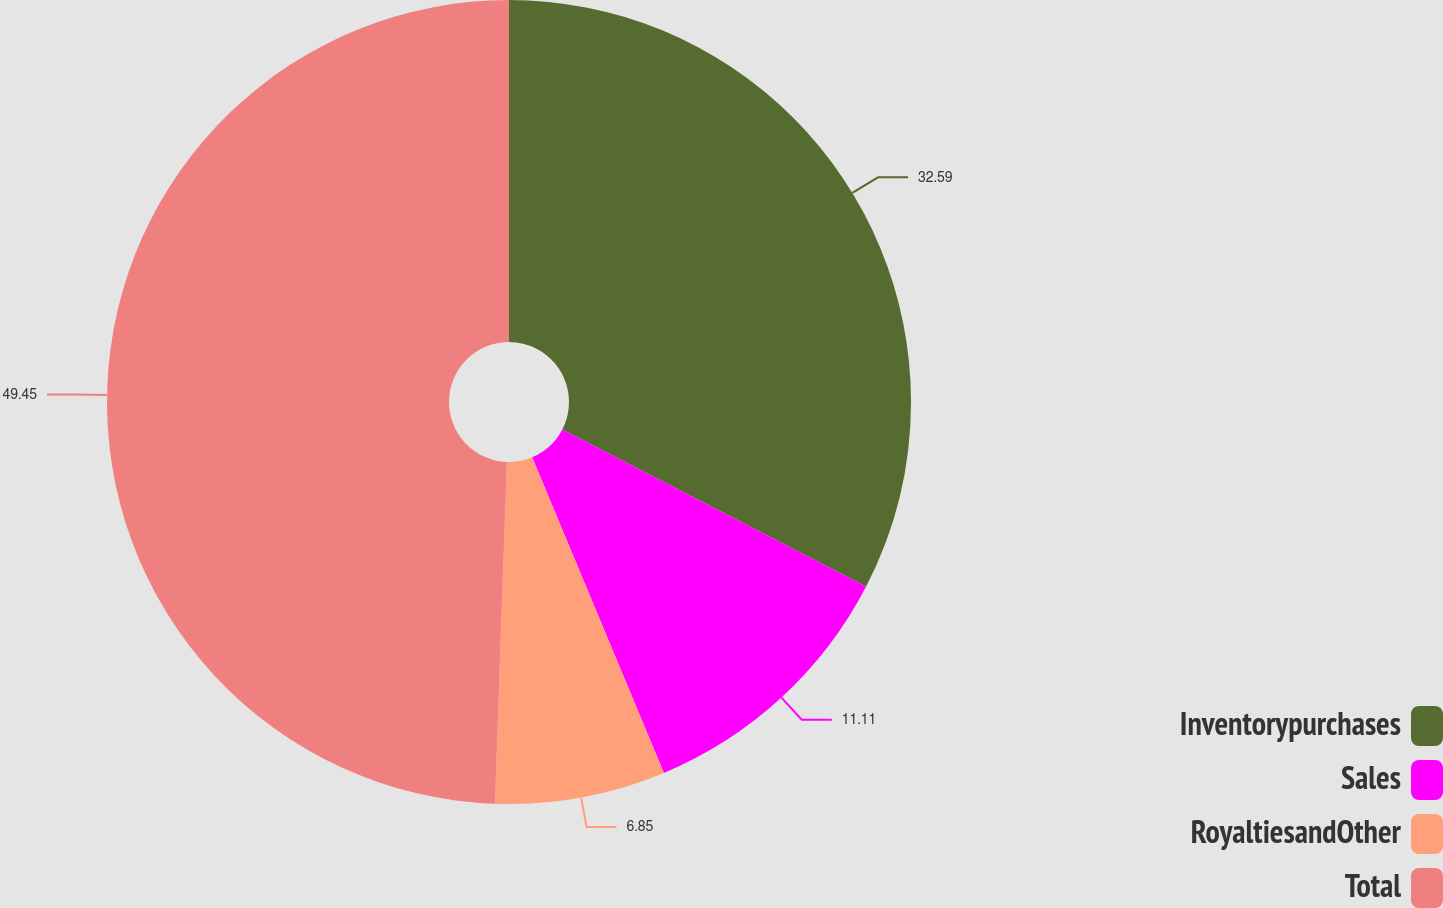Convert chart. <chart><loc_0><loc_0><loc_500><loc_500><pie_chart><fcel>Inventorypurchases<fcel>Sales<fcel>RoyaltiesandOther<fcel>Total<nl><fcel>32.59%<fcel>11.11%<fcel>6.85%<fcel>49.44%<nl></chart> 